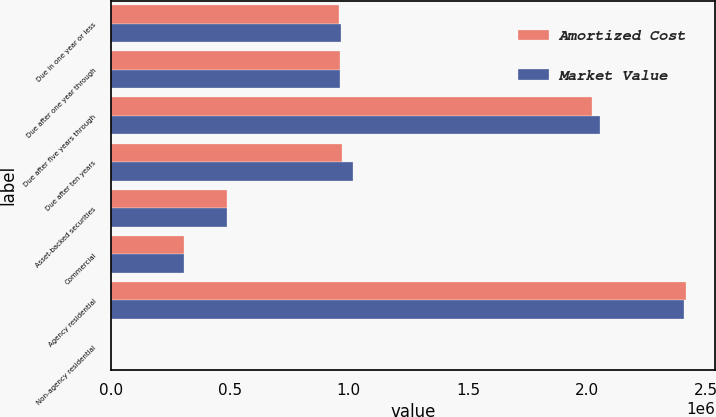Convert chart. <chart><loc_0><loc_0><loc_500><loc_500><stacked_bar_chart><ecel><fcel>Due in one year or less<fcel>Due after one year through<fcel>Due after five years through<fcel>Due after ten years<fcel>Asset-backed securities<fcel>Commercial<fcel>Agency residential<fcel>Non-agency residential<nl><fcel>Amortized Cost<fcel>956945<fcel>961958<fcel>2.02022e+06<fcel>971674<fcel>488824<fcel>308827<fcel>2.4159e+06<fcel>642<nl><fcel>Market Value<fcel>966970<fcel>961958<fcel>2.05273e+06<fcel>1.01596e+06<fcel>488648<fcel>306932<fcel>2.40547e+06<fcel>641<nl></chart> 